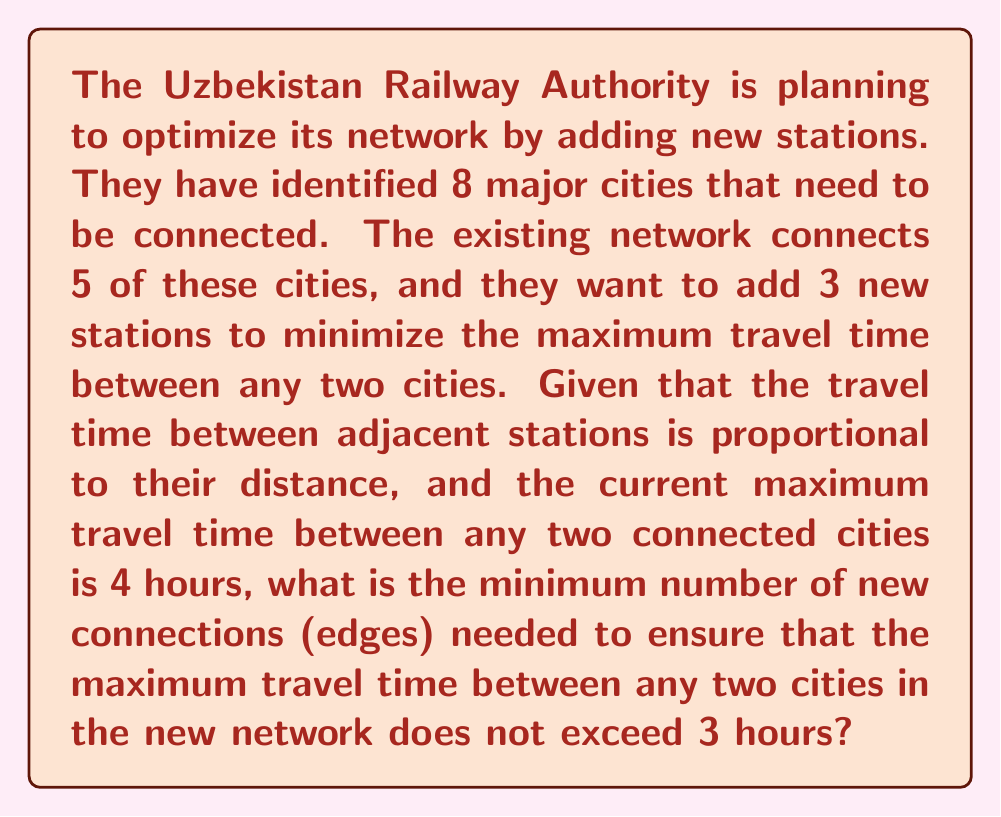Could you help me with this problem? Let's approach this step-by-step using graph theory:

1) We can model this problem as a graph where cities are vertices and railway connections are edges.

2) Initially, we have 5 connected cities. Let's call this initial graph $G$.

3) We need to add 3 new vertices (stations) and some edges to create a new graph $G'$ with 8 vertices total.

4) The goal is to minimize the diameter of $G'$. The diameter of a graph is the maximum distance (in our case, travel time) between any two vertices.

5) Currently, the diameter of $G$ is 4 hours. We need to reduce this to 3 hours or less in $G'$.

6) In graph theory, to reduce the diameter from 4 to 3, we need to ensure that any two vertices in $G'$ are at most 3 edges apart.

7) The most efficient way to do this is to position the new stations strategically to create "shortcuts" in the network.

8) In the worst case scenario of the initial graph $G$, it could be a linear path of 5 vertices. To reduce the diameter to 3, we need to connect the new vertices in a way that creates alternative paths.

9) The minimum number of new edges needed would be:
   - 1 edge to connect each new vertex to the existing network: 3 edges
   - 2 additional edges to create shortcuts and ensure the 3-hour maximum travel time

10) Therefore, the minimum total number of new edges needed is 3 + 2 = 5.

This solution assumes the new stations can be placed optimally. In a real-world scenario, geographical constraints would also need to be considered.
Answer: The minimum number of new connections (edges) needed is 5. 